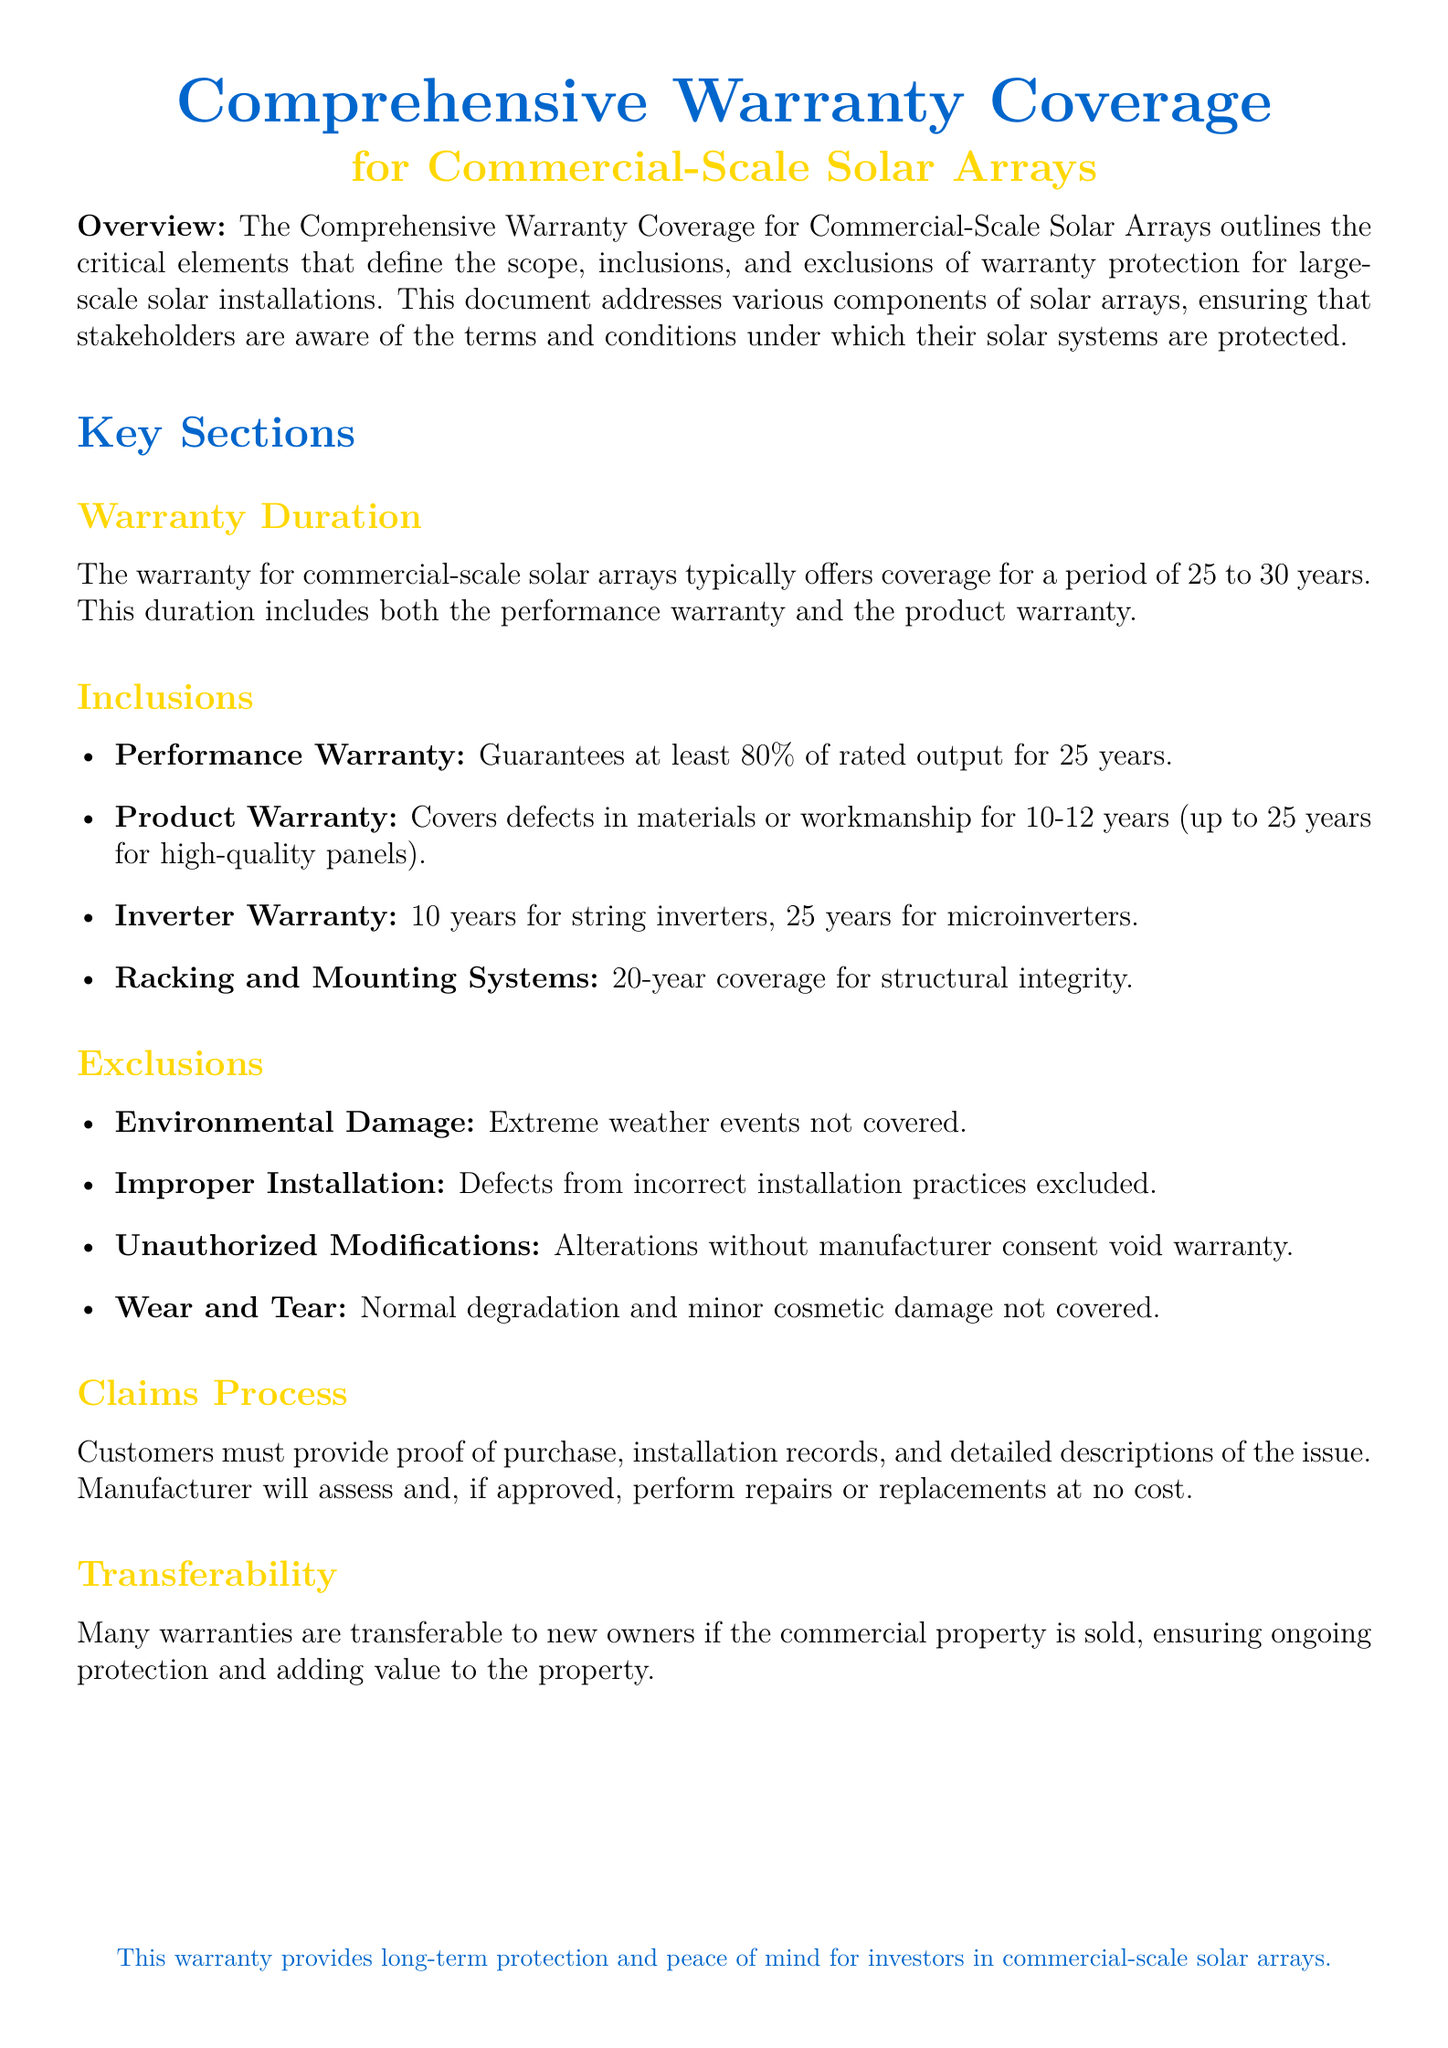What is the warranty duration for commercial-scale solar arrays? The document states that the warranty typically offers coverage for 25 to 30 years.
Answer: 25 to 30 years What percentage of rated output is guaranteed under the performance warranty? The performance warranty guarantees at least 80% of rated output for 25 years.
Answer: 80% How long is the product warranty coverage? It covers defects in materials or workmanship for 10-12 years (up to 25 years for high-quality panels).
Answer: 10-12 years What is the coverage duration for string inverters? The inverter warranty for string inverters is 10 years.
Answer: 10 years Which type of damage is excluded from the warranty? Environmental damage due to extreme weather events is specifically mentioned as excluded.
Answer: Extreme weather events What must customers provide to initiate a claims process? Customers must provide proof of purchase, installation records, and detailed descriptions of the issue.
Answer: Proof of purchase Is the warranty transferable to new owners? The document mentions that many warranties are transferable to new owners if the commercial property is sold.
Answer: Yes What is covered under the racking and mounting systems warranty? It provides 20-year coverage for structural integrity.
Answer: 20 years What constitutes an exclusion regarding installation? Improper installation practices are specified as exclusions in the warranty coverage.
Answer: Improper installation 